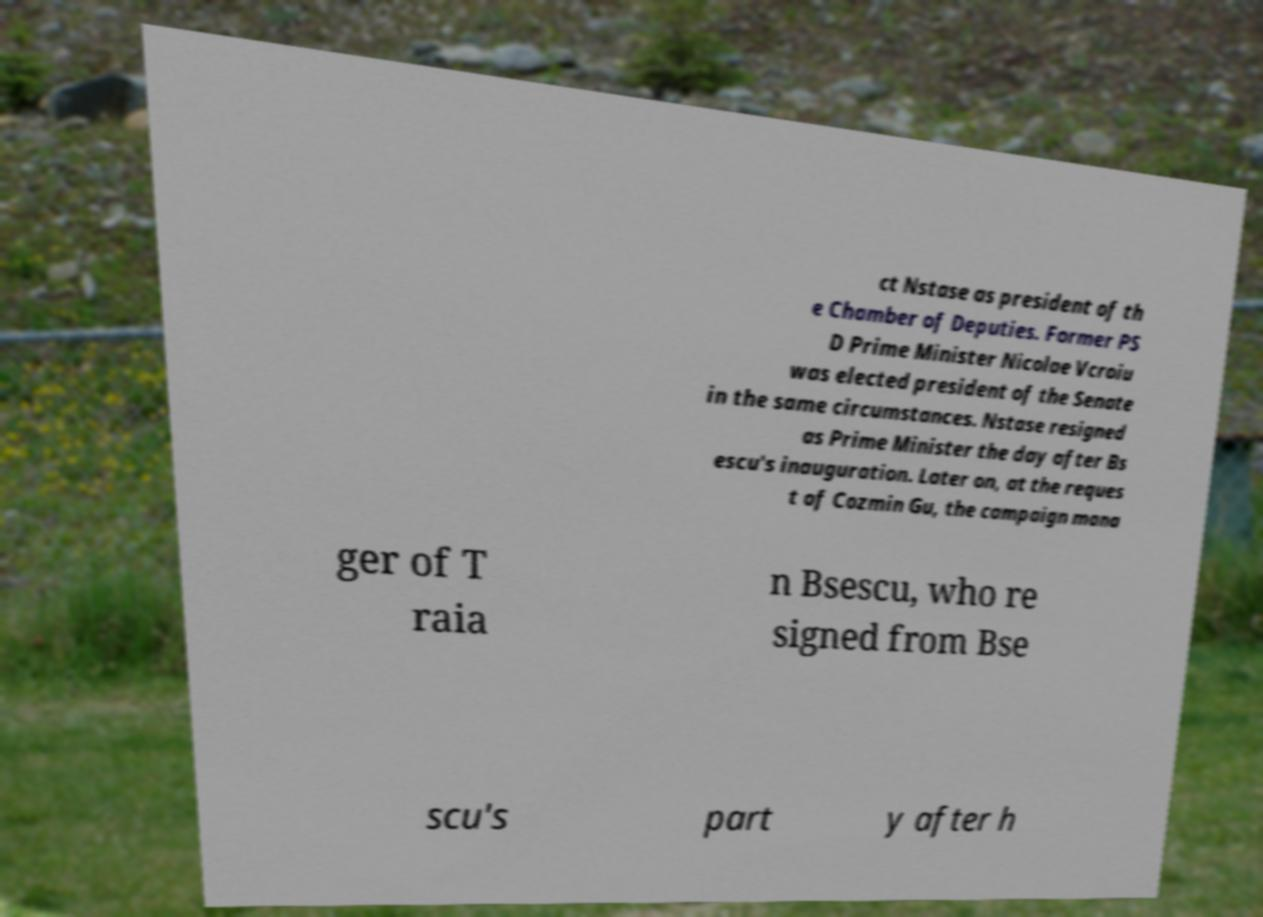Can you read and provide the text displayed in the image?This photo seems to have some interesting text. Can you extract and type it out for me? ct Nstase as president of th e Chamber of Deputies. Former PS D Prime Minister Nicolae Vcroiu was elected president of the Senate in the same circumstances. Nstase resigned as Prime Minister the day after Bs escu's inauguration. Later on, at the reques t of Cozmin Gu, the campaign mana ger of T raia n Bsescu, who re signed from Bse scu's part y after h 